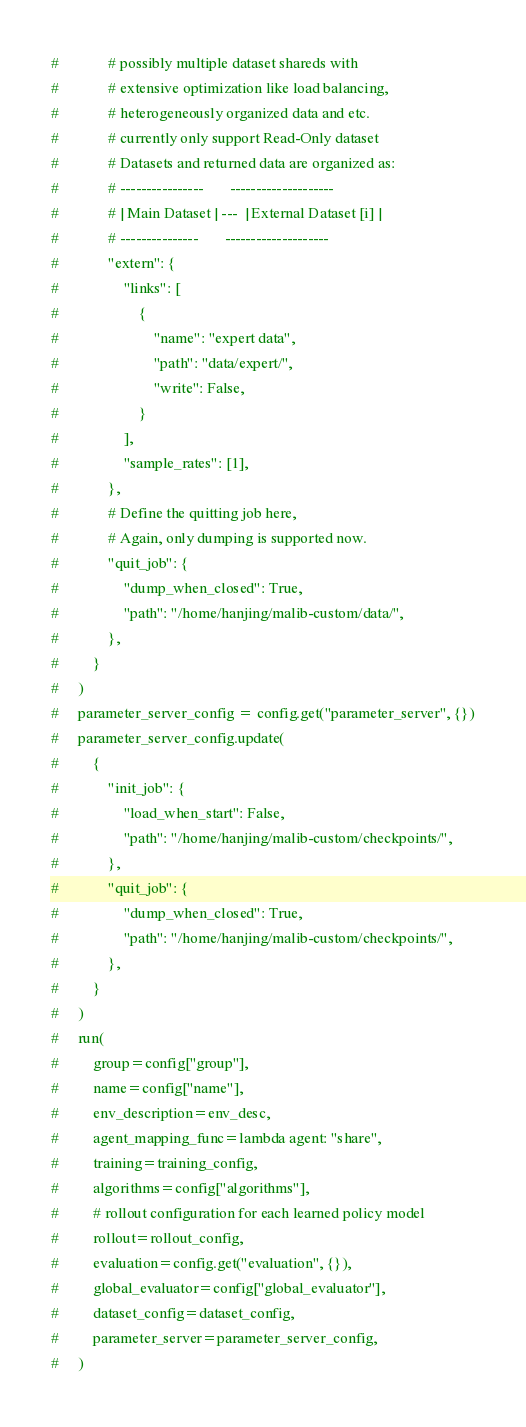Convert code to text. <code><loc_0><loc_0><loc_500><loc_500><_Python_>#             # possibly multiple dataset shareds with
#             # extensive optimization like load balancing,
#             # heterogeneously organized data and etc.
#             # currently only support Read-Only dataset
#             # Datasets and returned data are organized as:
#             # ----------------       --------------------
#             # | Main Dataset | ---  | External Dataset [i] |
#             # ---------------       --------------------
#             "extern": {
#                 "links": [
#                     {
#                         "name": "expert data",
#                         "path": "data/expert/",
#                         "write": False,
#                     }
#                 ],
#                 "sample_rates": [1],
#             },
#             # Define the quitting job here,
#             # Again, only dumping is supported now.
#             "quit_job": {
#                 "dump_when_closed": True,
#                 "path": "/home/hanjing/malib-custom/data/",
#             },
#         }
#     )
#     parameter_server_config = config.get("parameter_server", {})
#     parameter_server_config.update(
#         {
#             "init_job": {
#                 "load_when_start": False,
#                 "path": "/home/hanjing/malib-custom/checkpoints/",
#             },
#             "quit_job": {
#                 "dump_when_closed": True,
#                 "path": "/home/hanjing/malib-custom/checkpoints/",
#             },
#         }
#     )
#     run(
#         group=config["group"],
#         name=config["name"],
#         env_description=env_desc,
#         agent_mapping_func=lambda agent: "share",
#         training=training_config,
#         algorithms=config["algorithms"],
#         # rollout configuration for each learned policy model
#         rollout=rollout_config,
#         evaluation=config.get("evaluation", {}),
#         global_evaluator=config["global_evaluator"],
#         dataset_config=dataset_config,
#         parameter_server=parameter_server_config,
#     )
</code> 